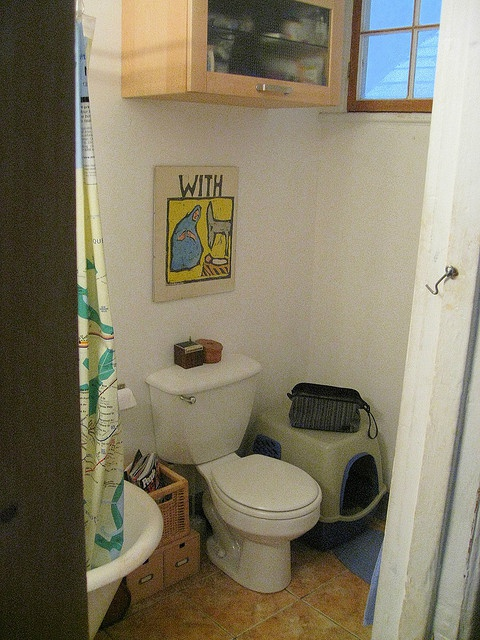Describe the objects in this image and their specific colors. I can see toilet in black, gray, and darkgray tones, sink in black, tan, gray, and olive tones, handbag in black, gray, and darkgreen tones, book in black, gray, and maroon tones, and book in black, gray, and maroon tones in this image. 